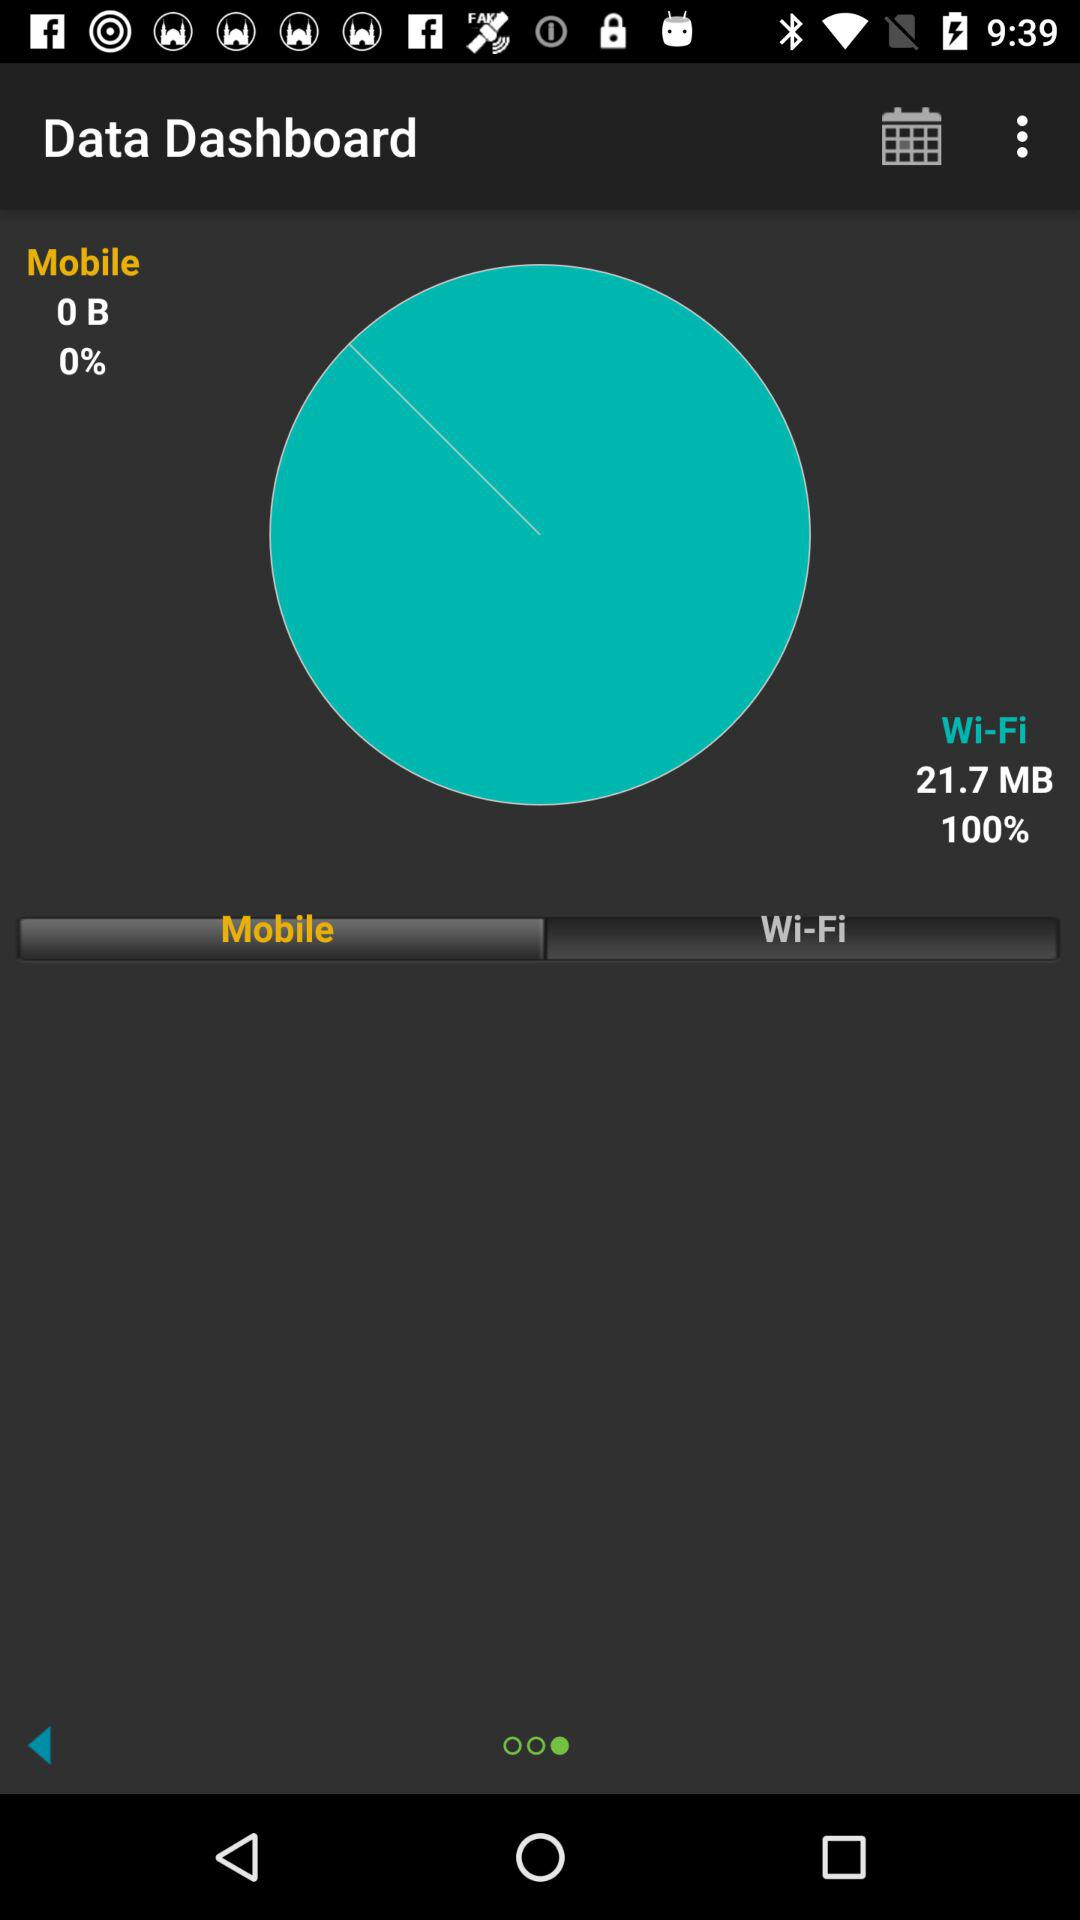What is the speed of the WiFi?
When the provided information is insufficient, respond with <no answer>. <no answer> 